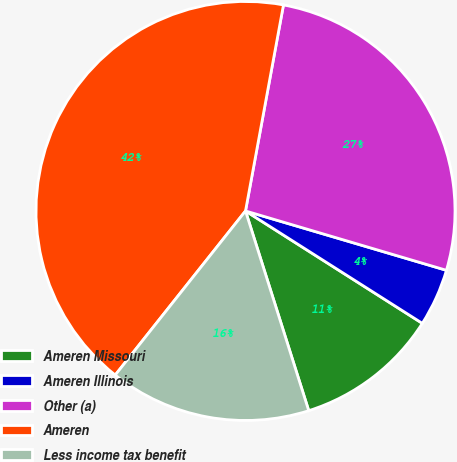<chart> <loc_0><loc_0><loc_500><loc_500><pie_chart><fcel>Ameren Missouri<fcel>Ameren Illinois<fcel>Other (a)<fcel>Ameren<fcel>Less income tax benefit<nl><fcel>11.11%<fcel>4.44%<fcel>26.67%<fcel>42.22%<fcel>15.56%<nl></chart> 